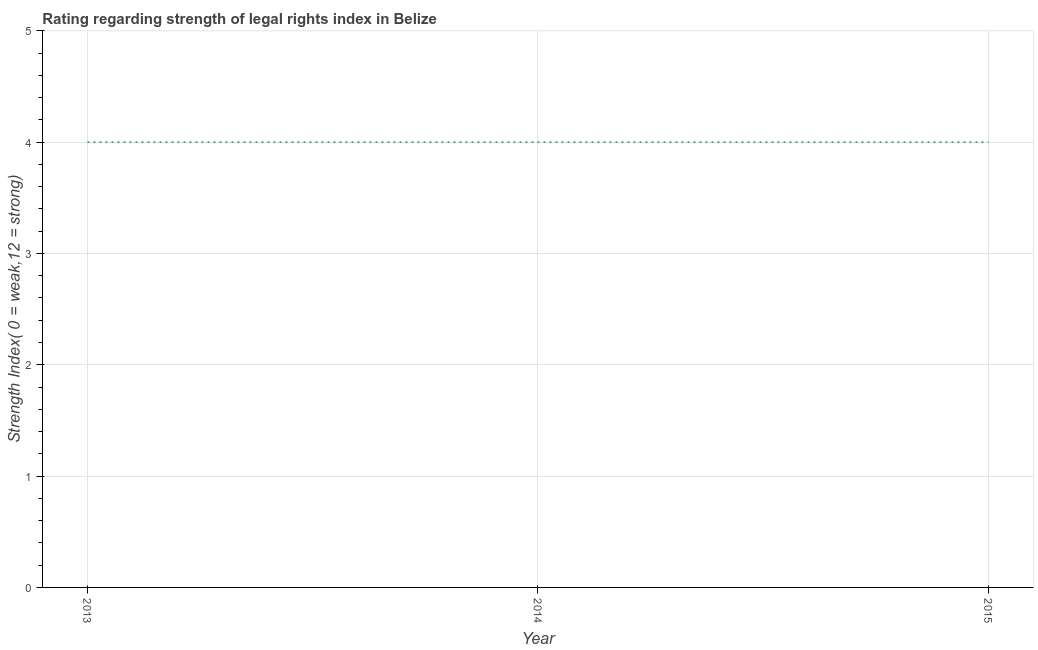What is the strength of legal rights index in 2015?
Provide a short and direct response. 4. Across all years, what is the maximum strength of legal rights index?
Your response must be concise. 4. Across all years, what is the minimum strength of legal rights index?
Your answer should be compact. 4. In which year was the strength of legal rights index maximum?
Provide a succinct answer. 2013. In which year was the strength of legal rights index minimum?
Keep it short and to the point. 2013. What is the sum of the strength of legal rights index?
Your response must be concise. 12. Do a majority of the years between 2013 and 2015 (inclusive) have strength of legal rights index greater than 4.8 ?
Your answer should be very brief. No. Is the strength of legal rights index in 2013 less than that in 2014?
Your answer should be compact. No. Is the difference between the strength of legal rights index in 2013 and 2014 greater than the difference between any two years?
Give a very brief answer. Yes. Does the graph contain grids?
Offer a terse response. Yes. What is the title of the graph?
Your answer should be very brief. Rating regarding strength of legal rights index in Belize. What is the label or title of the X-axis?
Offer a very short reply. Year. What is the label or title of the Y-axis?
Offer a terse response. Strength Index( 0 = weak,12 = strong). What is the Strength Index( 0 = weak,12 = strong) in 2013?
Your answer should be very brief. 4. What is the Strength Index( 0 = weak,12 = strong) of 2014?
Offer a terse response. 4. What is the Strength Index( 0 = weak,12 = strong) of 2015?
Offer a terse response. 4. What is the difference between the Strength Index( 0 = weak,12 = strong) in 2013 and 2015?
Offer a terse response. 0. What is the difference between the Strength Index( 0 = weak,12 = strong) in 2014 and 2015?
Ensure brevity in your answer.  0. What is the ratio of the Strength Index( 0 = weak,12 = strong) in 2013 to that in 2014?
Make the answer very short. 1. What is the ratio of the Strength Index( 0 = weak,12 = strong) in 2013 to that in 2015?
Provide a short and direct response. 1. What is the ratio of the Strength Index( 0 = weak,12 = strong) in 2014 to that in 2015?
Your answer should be compact. 1. 